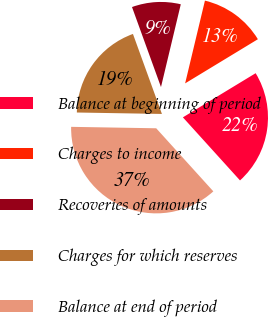Convert chart. <chart><loc_0><loc_0><loc_500><loc_500><pie_chart><fcel>Balance at beginning of period<fcel>Charges to income<fcel>Recoveries of amounts<fcel>Charges for which reserves<fcel>Balance at end of period<nl><fcel>21.97%<fcel>12.58%<fcel>9.27%<fcel>19.2%<fcel>36.98%<nl></chart> 